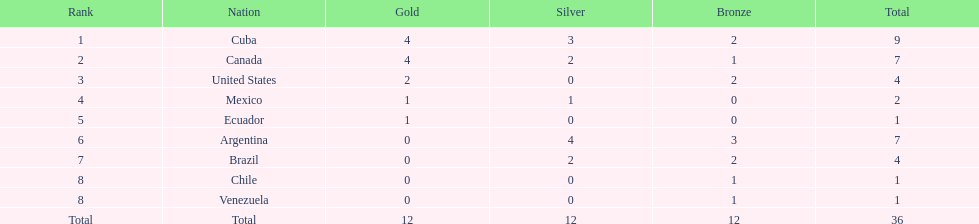How many total medals were there all together? 36. 